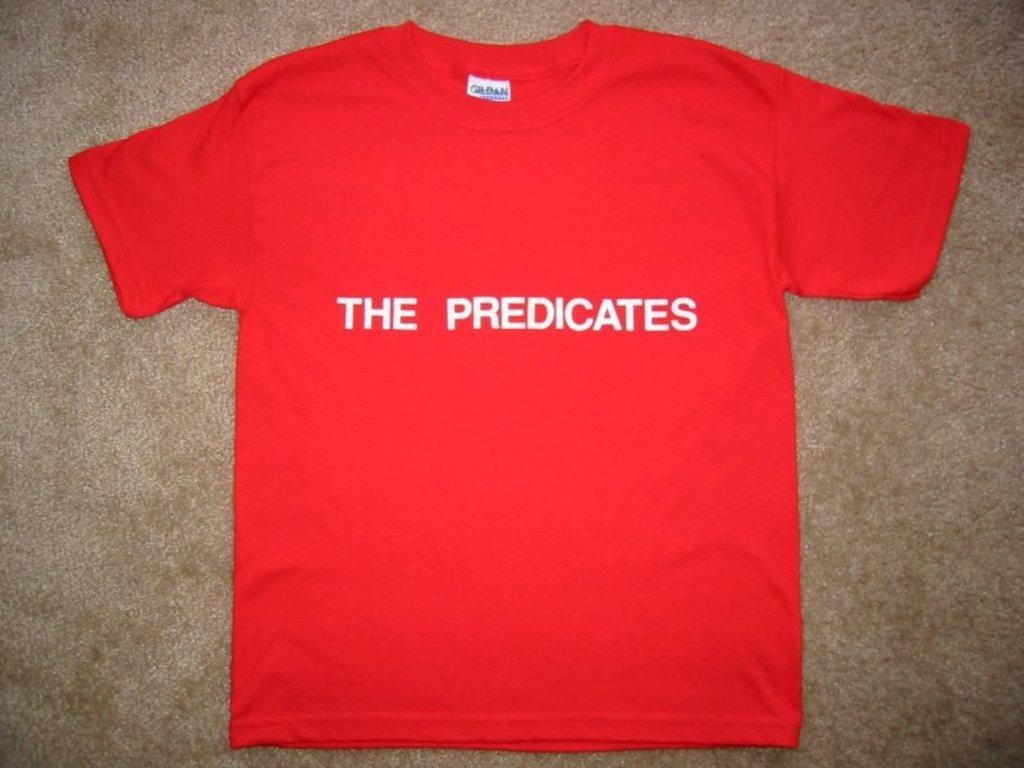Please provide a concise description of this image. In the center of the image there is a t-shirt placed on the ground. 